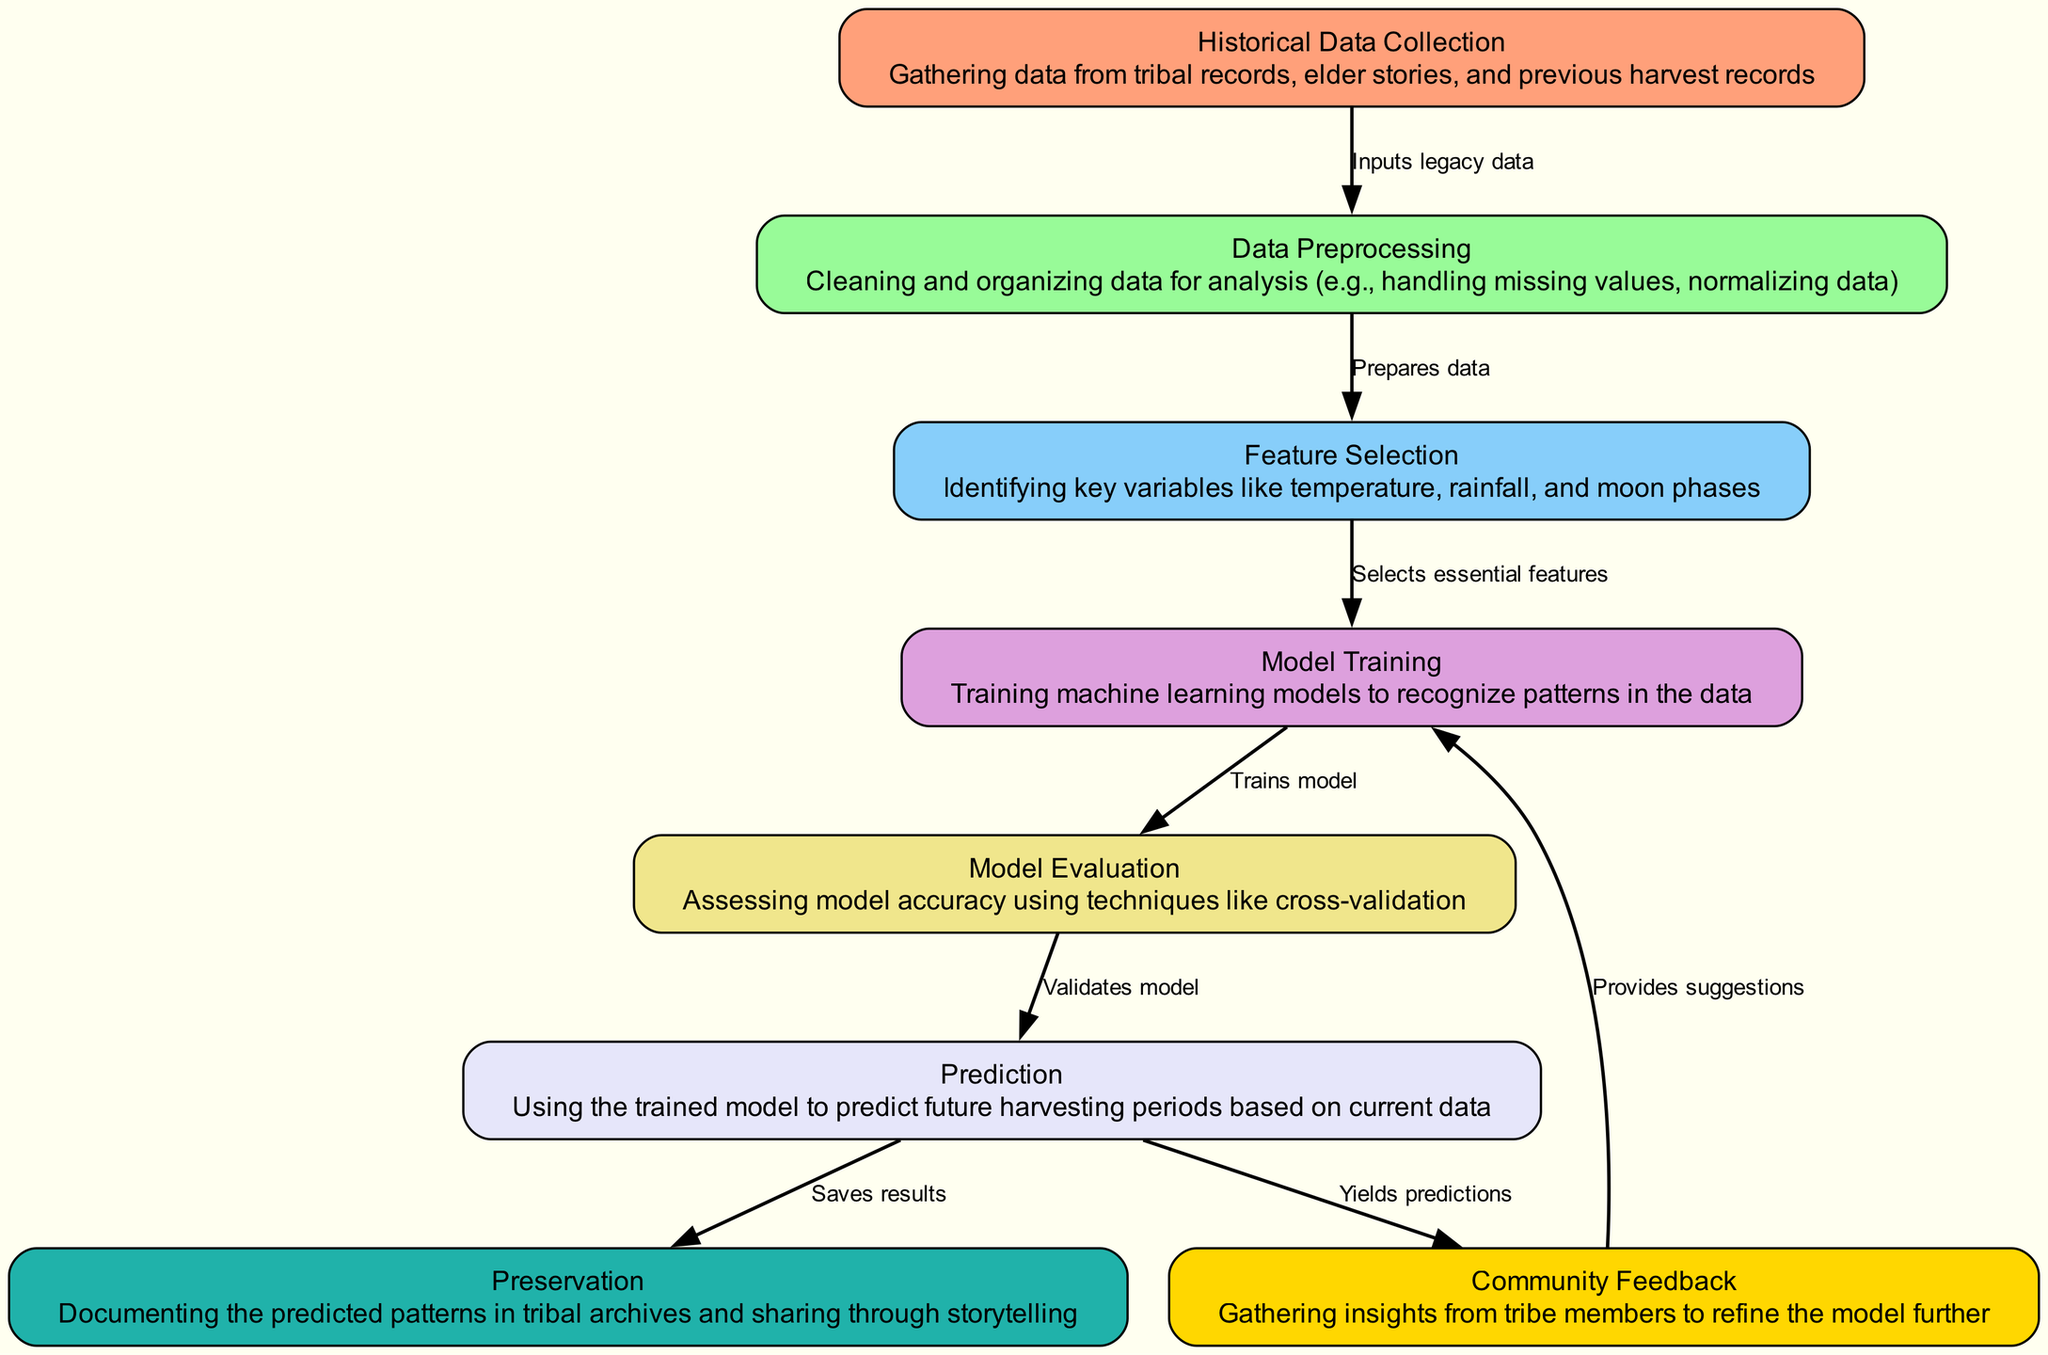What is the first step in the diagram? The first step in the diagram is "Historical Data Collection," which involves gathering data from various sources like tribal records and elder stories.
Answer: Historical Data Collection How many nodes are present in the diagram? The diagram includes 8 nodes, as detailed in the data provided.
Answer: 8 What is the purpose of the "Model Evaluation" node? The "Model Evaluation" node assesses the accuracy of the trained model utilizing techniques like cross-validation to ensure its reliability.
Answer: Assessing model accuracy Which node directly follows "Feature Selection"? "Model Training" directly follows "Feature Selection," indicating the process where machine learning models are trained using the selected features.
Answer: Model Training What does "Community Feedback" contribute to the process? "Community Feedback" provides suggestions that help refine the model after predictions are made, ensuring cultural insights are incorporated.
Answer: Provides suggestions Which two nodes are related to the output actions? "Prediction" and "Preservation" are related to output actions, as they involve yielding predictions and documenting patterns respectively.
Answer: Prediction and Preservation What is the output of the "Prediction" node? The output of the "Prediction" node is predictions based on the data processed through previous nodes, which are informed by the model trained earlier.
Answer: Yields predictions Which node handles the cleaning and organizing of data? "Data Preprocessing" is responsible for cleaning and organizing the gathered historical data for subsequent analysis.
Answer: Data Preprocessing What links the "Model Evaluation" to "Prediction"? The edge labeled "Validates model" links "Model Evaluation" to "Prediction," indicating that model validation must occur before making predictions.
Answer: Validates model What type of information do the nodes represent? The nodes represent various stages in the machine learning process that apply historical data to predict seasonal harvesting patterns.
Answer: Stages in the machine learning process 